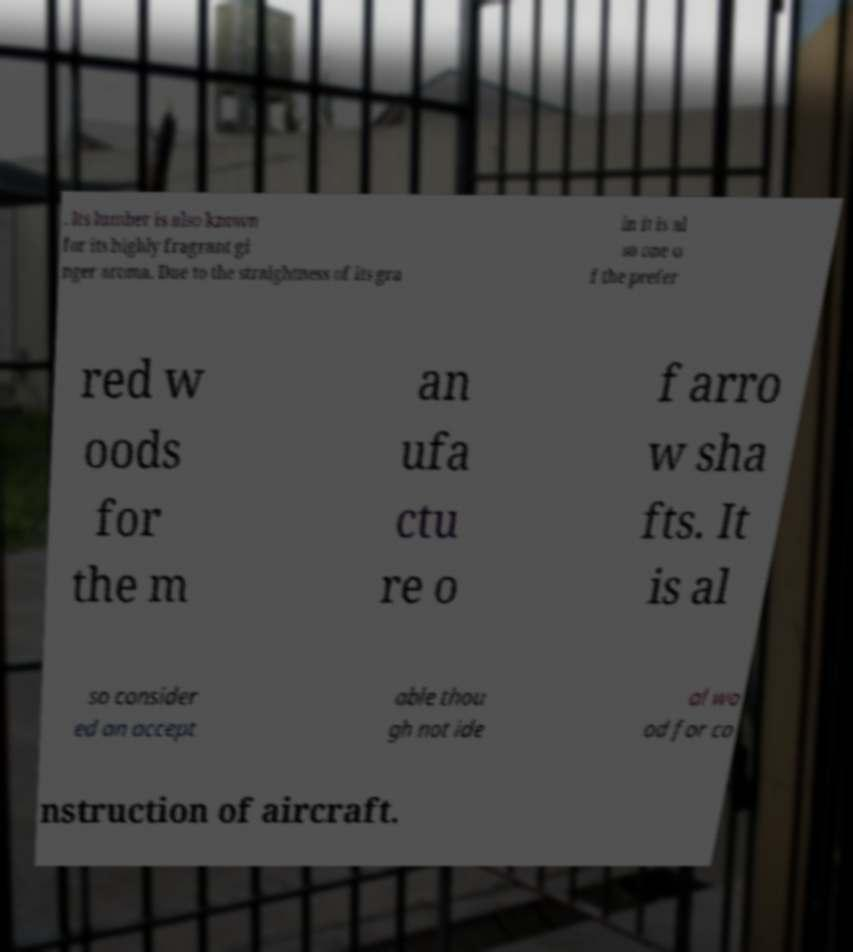Can you read and provide the text displayed in the image?This photo seems to have some interesting text. Can you extract and type it out for me? . Its lumber is also known for its highly fragrant gi nger aroma. Due to the straightness of its gra in it is al so one o f the prefer red w oods for the m an ufa ctu re o f arro w sha fts. It is al so consider ed an accept able thou gh not ide al wo od for co nstruction of aircraft. 